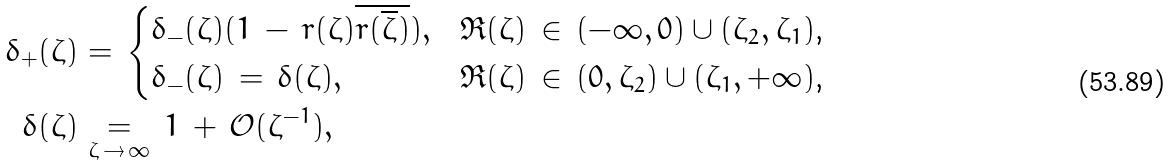<formula> <loc_0><loc_0><loc_500><loc_500>\delta _ { + } ( \zeta ) & = \, \begin{cases} \delta _ { - } ( \zeta ) ( 1 \, - \, r ( \zeta ) \overline { r ( \overline { \zeta } ) } ) , & \text {$\Re (\zeta) \, \in \, (-\infty,0) \cup (\zeta_{2},\zeta_{1})$,} \\ \delta _ { - } ( \zeta ) \, = \, \delta ( \zeta ) , & \text {$\Re (\zeta) \, \in \, (0, \zeta_{2}) \cup (\zeta_{1},+\infty)$,} \end{cases} \\ \delta ( \zeta ) & \underset { \zeta \, \to \, \infty } { = } \, 1 \, + \, \mathcal { O } ( \zeta ^ { - 1 } ) ,</formula> 